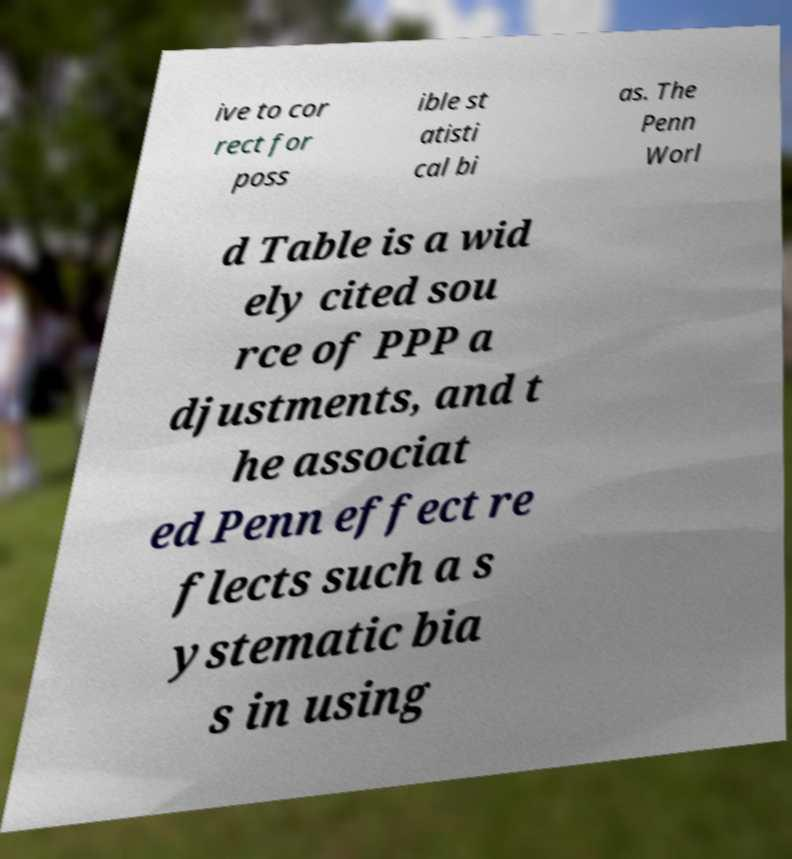Can you accurately transcribe the text from the provided image for me? ive to cor rect for poss ible st atisti cal bi as. The Penn Worl d Table is a wid ely cited sou rce of PPP a djustments, and t he associat ed Penn effect re flects such a s ystematic bia s in using 